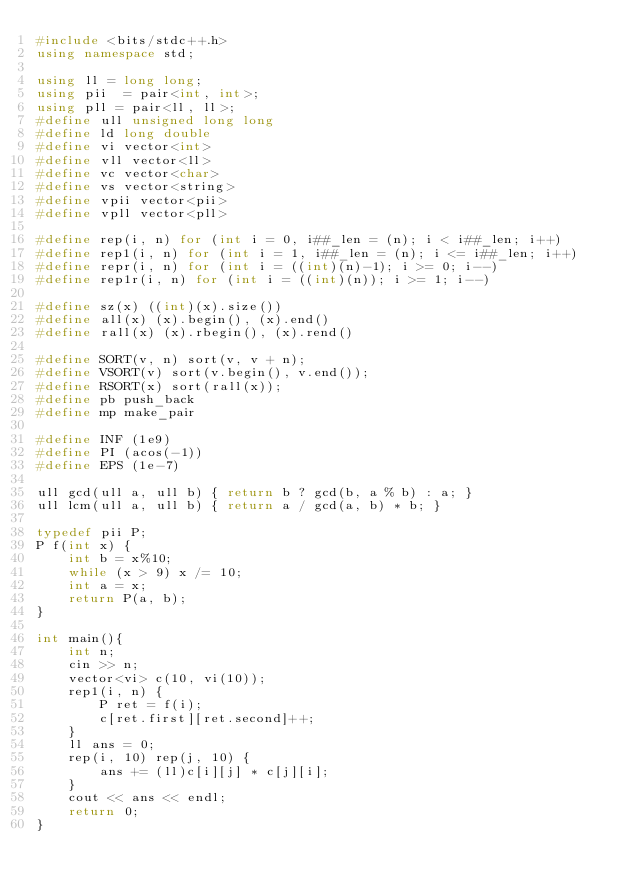Convert code to text. <code><loc_0><loc_0><loc_500><loc_500><_C++_>#include <bits/stdc++.h>
using namespace std;

using ll = long long;
using pii  = pair<int, int>;
using pll = pair<ll, ll>;
#define ull unsigned long long
#define ld long double
#define vi vector<int>
#define vll vector<ll>
#define vc vector<char>
#define vs vector<string>
#define vpii vector<pii>
#define vpll vector<pll>

#define rep(i, n) for (int i = 0, i##_len = (n); i < i##_len; i++)
#define rep1(i, n) for (int i = 1, i##_len = (n); i <= i##_len; i++)
#define repr(i, n) for (int i = ((int)(n)-1); i >= 0; i--)
#define rep1r(i, n) for (int i = ((int)(n)); i >= 1; i--)

#define sz(x) ((int)(x).size())
#define all(x) (x).begin(), (x).end()
#define rall(x) (x).rbegin(), (x).rend()

#define SORT(v, n) sort(v, v + n);
#define VSORT(v) sort(v.begin(), v.end());
#define RSORT(x) sort(rall(x));
#define pb push_back
#define mp make_pair

#define INF (1e9)
#define PI (acos(-1))
#define EPS (1e-7)

ull gcd(ull a, ull b) { return b ? gcd(b, a % b) : a; }
ull lcm(ull a, ull b) { return a / gcd(a, b) * b; }

typedef pii P;
P f(int x) {
    int b = x%10;
    while (x > 9) x /= 10;
    int a = x;
    return P(a, b);
}

int main(){
    int n;
    cin >> n;
    vector<vi> c(10, vi(10));
    rep1(i, n) {
        P ret = f(i);
        c[ret.first][ret.second]++;
    }
    ll ans = 0;
    rep(i, 10) rep(j, 10) {
        ans += (ll)c[i][j] * c[j][i];
    }
    cout << ans << endl;
    return 0;
}
</code> 